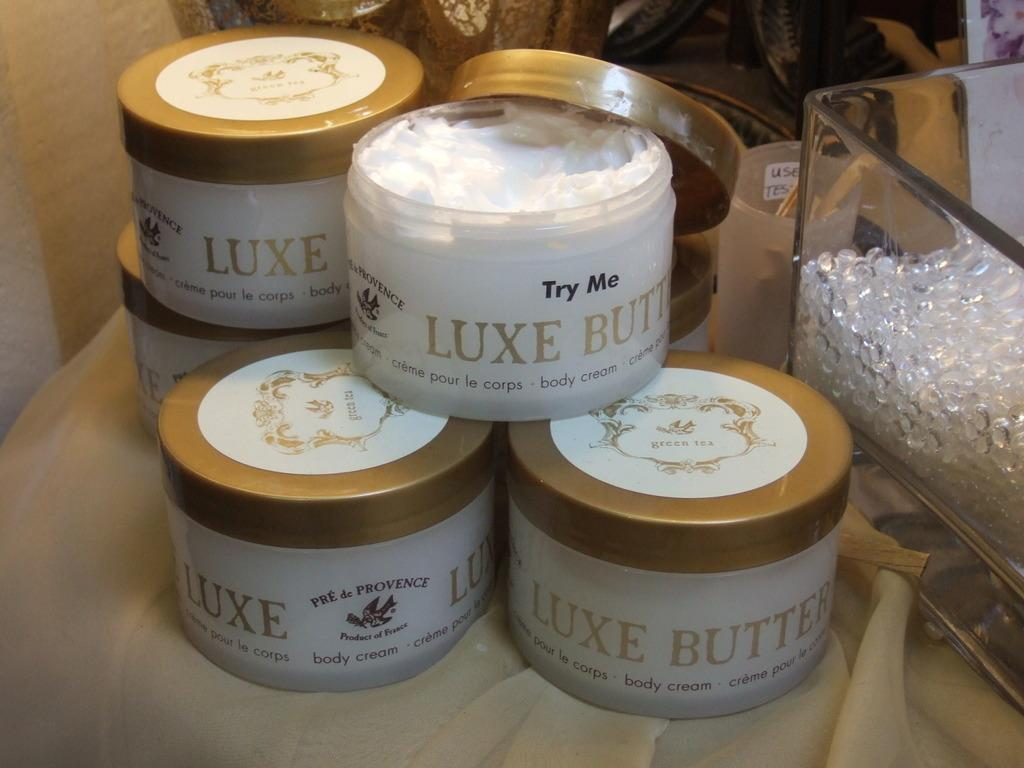<image>
Relay a brief, clear account of the picture shown. Body cream boxes in the brand name of Luxe butter 